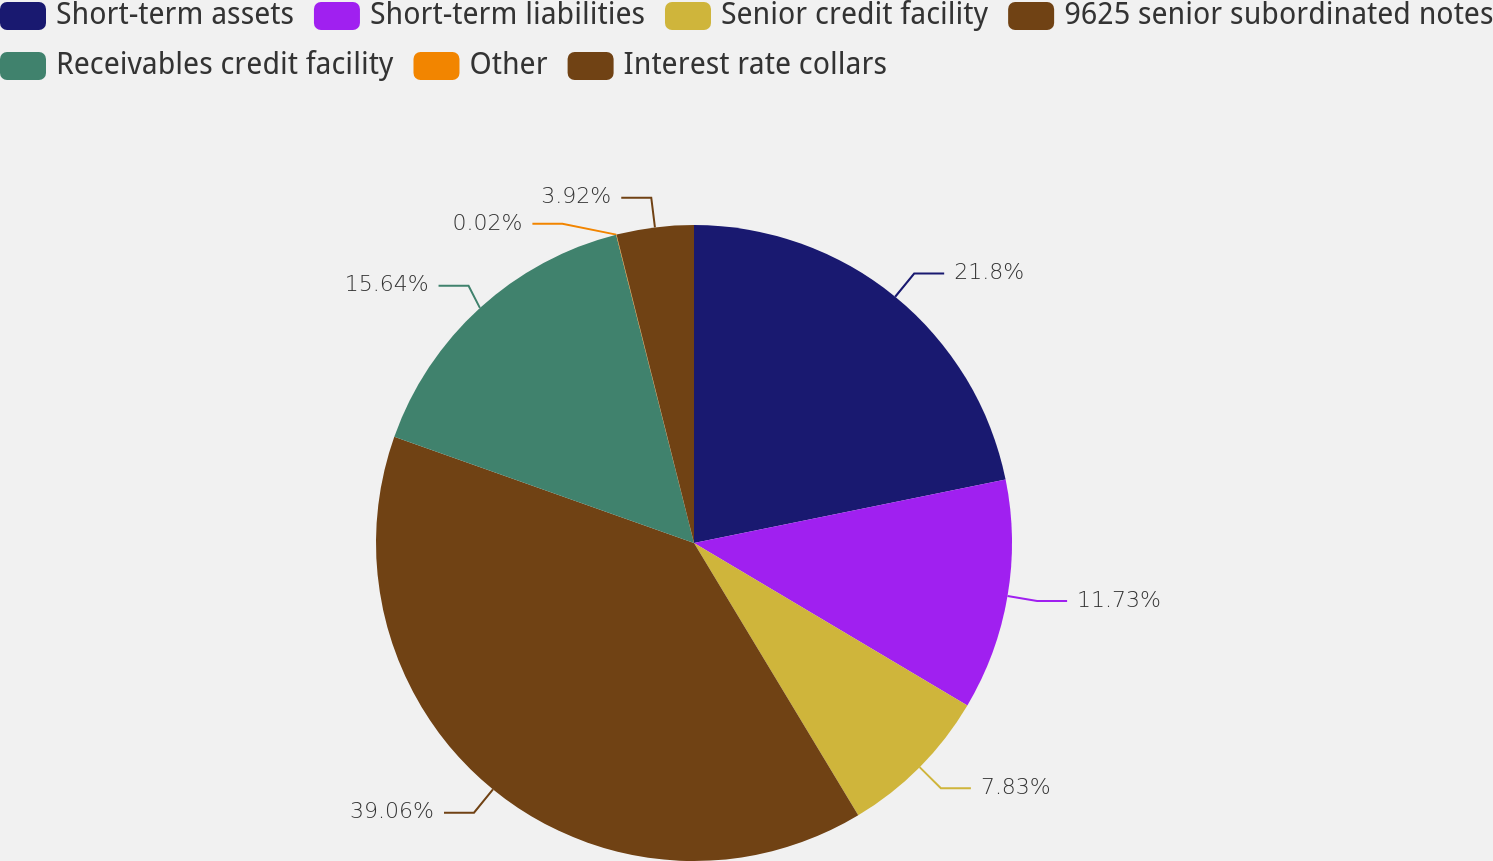<chart> <loc_0><loc_0><loc_500><loc_500><pie_chart><fcel>Short-term assets<fcel>Short-term liabilities<fcel>Senior credit facility<fcel>9625 senior subordinated notes<fcel>Receivables credit facility<fcel>Other<fcel>Interest rate collars<nl><fcel>21.81%<fcel>11.73%<fcel>7.83%<fcel>39.07%<fcel>15.64%<fcel>0.02%<fcel>3.92%<nl></chart> 